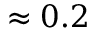Convert formula to latex. <formula><loc_0><loc_0><loc_500><loc_500>\approx 0 . 2</formula> 